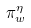Convert formula to latex. <formula><loc_0><loc_0><loc_500><loc_500>\pi _ { w } ^ { \eta }</formula> 